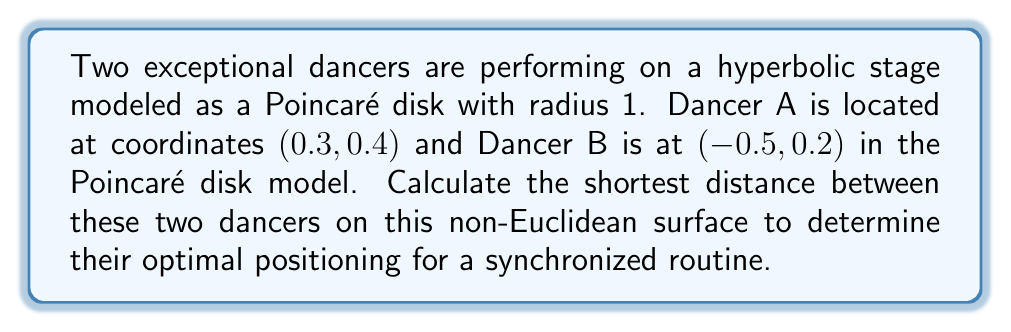Can you solve this math problem? To find the shortest distance between two points on a Poincaré disk, we need to use the hyperbolic distance formula. Let's approach this step-by-step:

1. First, we need to convert the given Cartesian coordinates to complex numbers:
   $z_1 = 0.3 + 0.4i$ (Dancer A)
   $z_2 = -0.5 + 0.2i$ (Dancer B)

2. The hyperbolic distance formula in the Poincaré disk model is:
   $$d(z_1, z_2) = 2\tanh^{-1}\left|\frac{z_1 - z_2}{1 - \overline{z_1}z_2}\right|$$

3. Let's calculate the numerator $(z_1 - z_2)$:
   $z_1 - z_2 = (0.3 + 0.4i) - (-0.5 + 0.2i) = 0.8 + 0.2i$

4. Now, let's calculate the denominator $(1 - \overline{z_1}z_2)$:
   $\overline{z_1} = 0.3 - 0.4i$
   $\overline{z_1}z_2 = (0.3 - 0.4i)(-0.5 + 0.2i) = -0.15 - 0.2i + 0.2i - 0.08i = -0.15 - 0.08i$
   $1 - \overline{z_1}z_2 = 1 - (-0.15 - 0.08i) = 1.15 + 0.08i$

5. Now we can form the fraction inside the absolute value:
   $$\frac{z_1 - z_2}{1 - \overline{z_1}z_2} = \frac{0.8 + 0.2i}{1.15 + 0.08i}$$

6. To calculate the absolute value of this complex fraction, we multiply by its complex conjugate:
   $$\left|\frac{0.8 + 0.2i}{1.15 + 0.08i}\right| = \sqrt{\frac{(0.8 + 0.2i)(0.8 - 0.2i)}{(1.15 + 0.08i)(1.15 - 0.08i)}} = \sqrt{\frac{0.68}{1.3289}} \approx 0.7155$$

7. Finally, we apply the hyperbolic arctangent and multiply by 2:
   $$d(z_1, z_2) = 2\tanh^{-1}(0.7155) \approx 1.7843$$

This value represents the hyperbolic distance between the two dancers on the Poincaré disk.
Answer: 1.7843 